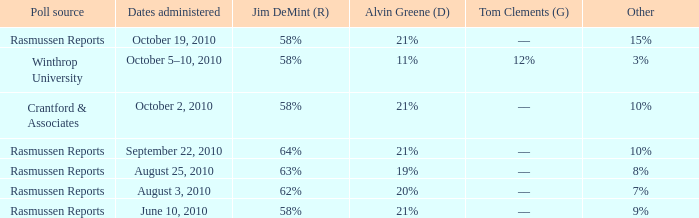What was the vote for Alvin Green when other was 9%? 21%. 